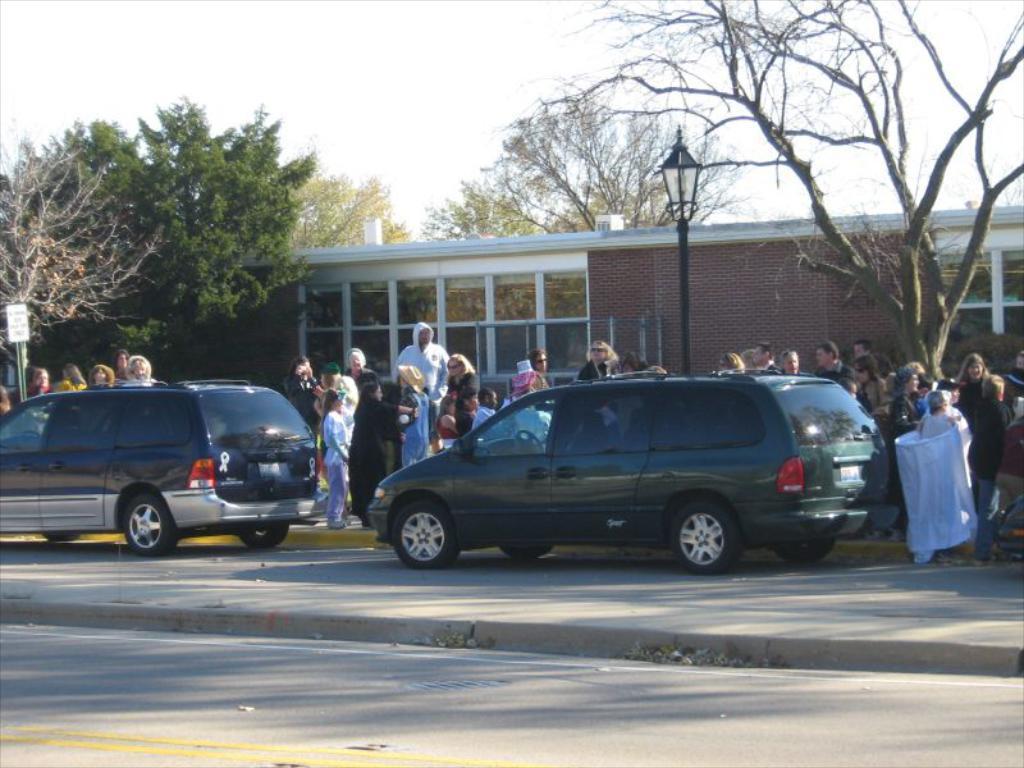How would you summarize this image in a sentence or two? This picture might be taken outside of the city and it is sunny. In this image, in the middle, we can see a car which is placed on the road. On the left side, we can also see another car which is placed on the road. In the background, we can see group of people standing, street lights, buildings, glass window, trees. On the top, we can see a sky, at the bottom there is a road and a footpath. 